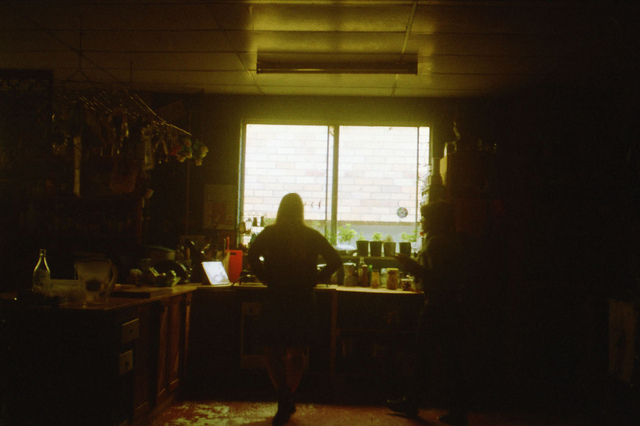Is this space used more for cooking or for other activities? This space seems to serve multiple purposes beyond just cooking. The presence of a laptop and various personal items suggest it also functions as a work or living area, blending practical and recreational uses. 